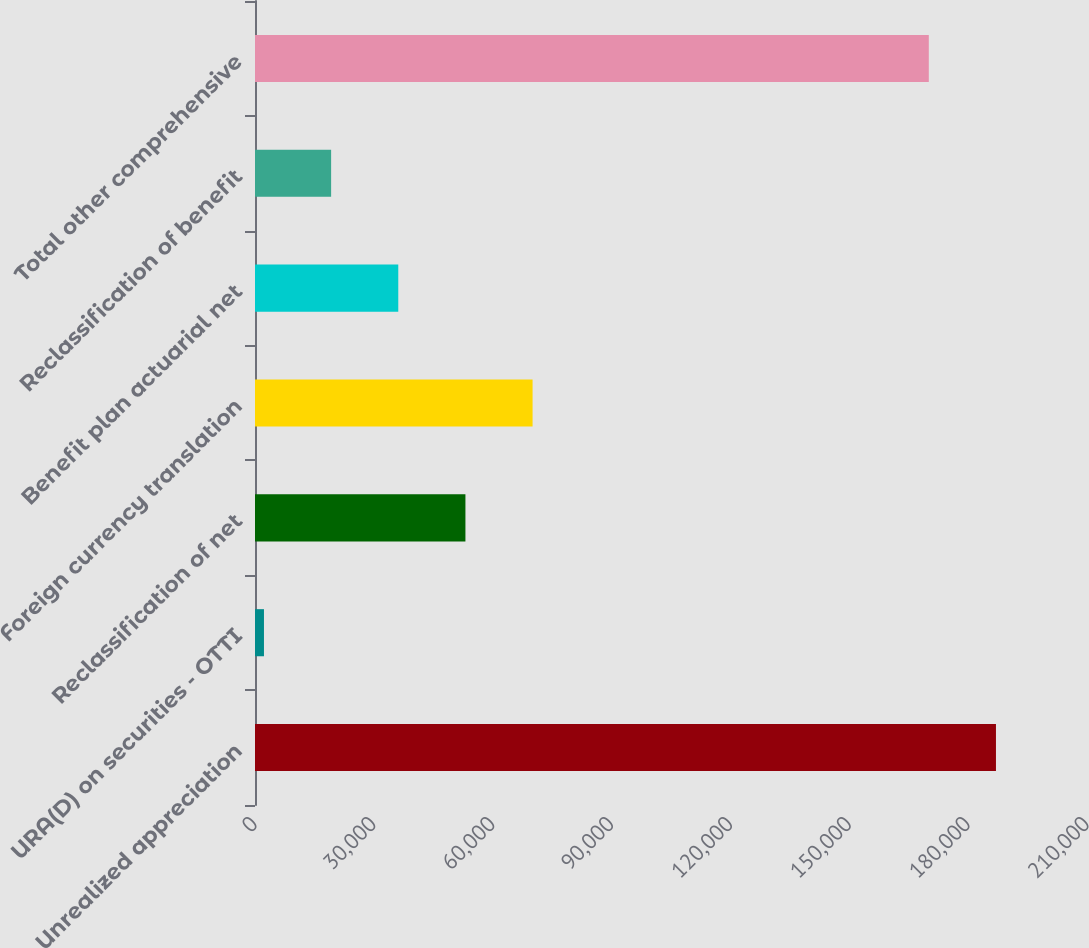Convert chart. <chart><loc_0><loc_0><loc_500><loc_500><bar_chart><fcel>Unrealized appreciation<fcel>URA(D) on securities - OTTI<fcel>Reclassification of net<fcel>Foreign currency translation<fcel>Benefit plan actuarial net<fcel>Reclassification of benefit<fcel>Total other comprehensive<nl><fcel>187021<fcel>2264<fcel>53113.1<fcel>70062.8<fcel>36163.4<fcel>19213.7<fcel>170071<nl></chart> 